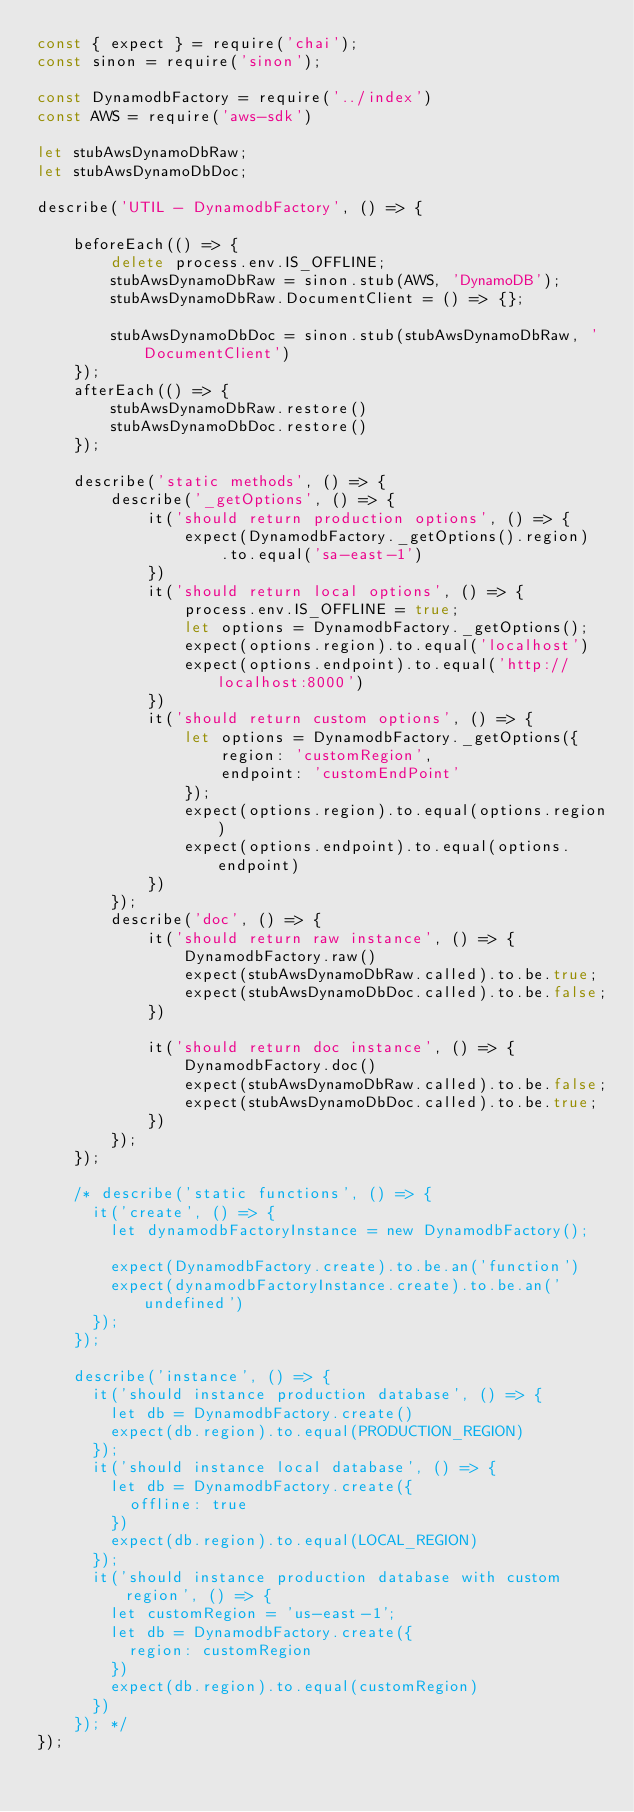Convert code to text. <code><loc_0><loc_0><loc_500><loc_500><_JavaScript_>const { expect } = require('chai');
const sinon = require('sinon');

const DynamodbFactory = require('../index')
const AWS = require('aws-sdk')

let stubAwsDynamoDbRaw;
let stubAwsDynamoDbDoc;

describe('UTIL - DynamodbFactory', () => {

    beforeEach(() => {
        delete process.env.IS_OFFLINE;
        stubAwsDynamoDbRaw = sinon.stub(AWS, 'DynamoDB');
        stubAwsDynamoDbRaw.DocumentClient = () => {};

        stubAwsDynamoDbDoc = sinon.stub(stubAwsDynamoDbRaw, 'DocumentClient')
    });
    afterEach(() => {
        stubAwsDynamoDbRaw.restore()
        stubAwsDynamoDbDoc.restore()
    });

    describe('static methods', () => {
        describe('_getOptions', () => {
            it('should return production options', () => {
                expect(DynamodbFactory._getOptions().region)
                    .to.equal('sa-east-1')
            })
            it('should return local options', () => {
                process.env.IS_OFFLINE = true;
                let options = DynamodbFactory._getOptions();
                expect(options.region).to.equal('localhost')
                expect(options.endpoint).to.equal('http://localhost:8000')
            })
            it('should return custom options', () => {
                let options = DynamodbFactory._getOptions({
                    region: 'customRegion',
                    endpoint: 'customEndPoint'
                });
                expect(options.region).to.equal(options.region)
                expect(options.endpoint).to.equal(options.endpoint)
            })
        });
        describe('doc', () => {
            it('should return raw instance', () => {
                DynamodbFactory.raw()
                expect(stubAwsDynamoDbRaw.called).to.be.true;
                expect(stubAwsDynamoDbDoc.called).to.be.false;
            })

            it('should return doc instance', () => {
                DynamodbFactory.doc()
                expect(stubAwsDynamoDbRaw.called).to.be.false;
                expect(stubAwsDynamoDbDoc.called).to.be.true;
            })
        });
    });

    /* describe('static functions', () => {
      it('create', () => {
        let dynamodbFactoryInstance = new DynamodbFactory();
  
        expect(DynamodbFactory.create).to.be.an('function')
        expect(dynamodbFactoryInstance.create).to.be.an('undefined')
      });
    });
  
    describe('instance', () => {
      it('should instance production database', () => {
        let db = DynamodbFactory.create()
        expect(db.region).to.equal(PRODUCTION_REGION)
      });
      it('should instance local database', () => {
        let db = DynamodbFactory.create({
          offline: true
        })
        expect(db.region).to.equal(LOCAL_REGION)
      });
      it('should instance production database with custom region', () => {
        let customRegion = 'us-east-1';
        let db = DynamodbFactory.create({
          region: customRegion
        })
        expect(db.region).to.equal(customRegion)
      })
    }); */
});
</code> 